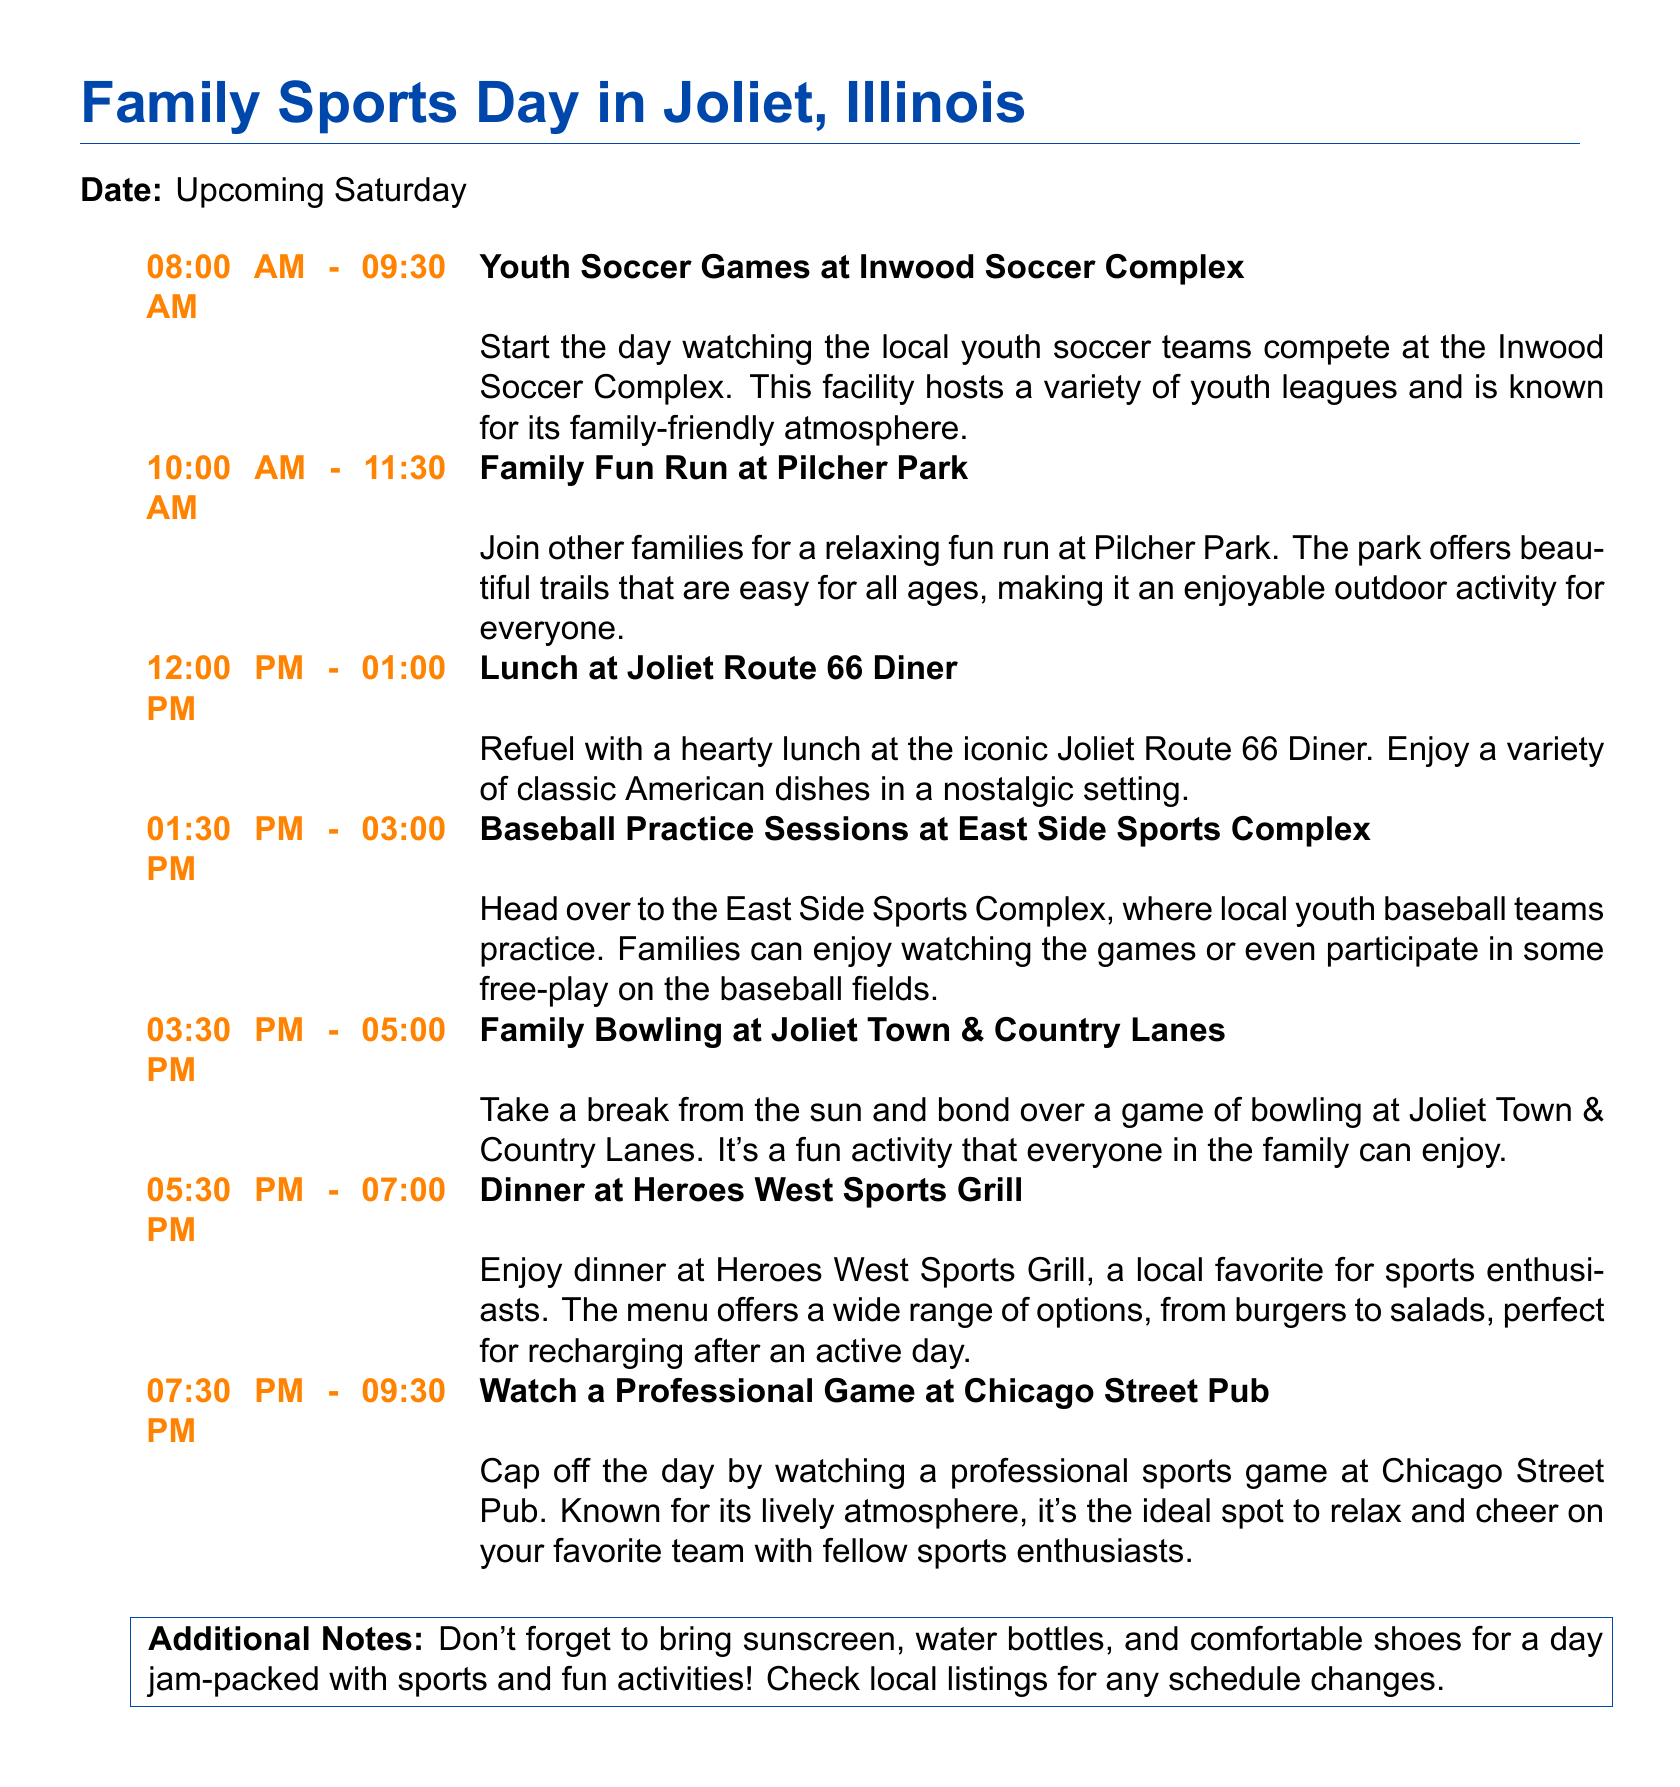What time does the Family Fun Run start? The Family Fun Run starts at 10:00 AM.
Answer: 10:00 AM Where is the Youth Soccer Games being held? The Youth Soccer Games are held at Inwood Soccer Complex.
Answer: Inwood Soccer Complex What is the lunch venue listed in the itinerary? The lunch venue is the Joliet Route 66 Diner.
Answer: Joliet Route 66 Diner How long is the Baseball Practice Sessions scheduled for? The Baseball Practice Sessions are scheduled for 1.5 hours, from 1:30 PM to 3:00 PM.
Answer: 1.5 hours What is the last activity of the day? The last activity of the day is watching a professional game at Chicago Street Pub.
Answer: Watching a professional game at Chicago Street Pub What should families bring for the day? Families should bring sunscreen, water bottles, and comfortable shoes.
Answer: Sunscreen, water bottles, and comfortable shoes How many sporting activities are planned for the day? There are six planned sporting activities in the itinerary.
Answer: Six What is the address for dinner at Heroes West Sports Grill? The document does not provide an address for Heroes West Sports Grill.
Answer: N/A What type of cuisine is served at the Joliet Route 66 Diner? The diner serves classic American dishes.
Answer: Classic American dishes 